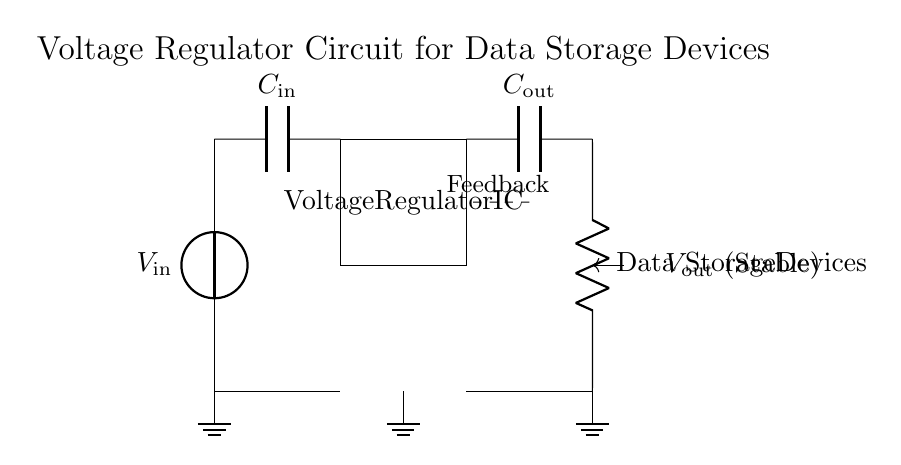What is the input voltage of this circuit? The input voltage is indicated as V in the circuit diagram. It is represented by the voltage source at the top-left corner, labeled with V in the diagram.
Answer: V in What type of component is the voltage regulator? The voltage regulator is represented by a rectangle in the diagram, and it's clearly labeled as a Voltage Regulator IC.
Answer: Voltage Regulator IC How many capacitors are present in the circuit? There are two capacitors shown in the diagram, one at the input and one at the output, labeled C in and C out respectively.
Answer: 2 What is the purpose of the feedback loop in this circuit? The feedback loop is shown by a dashed line connecting the output to the regulator, allowing the circuit to stabilize the output voltage based on the feedback received. This process is essential for maintaining a constant voltage despite variations in input or load.
Answer: Stabilizing output What do the load resistors represent in this circuit? The load resistor in this circuit is labeled as Data Storage Devices, indicating that this component simulates the electrical load seen by the power supply from the data storage system.
Answer: Data Storage Devices What is the output voltage labeled as in the diagram? The output voltage is labeled as V out in the circuit diagram, which signifies that it is the stable voltage output supplied to the load.
Answer: V out (Stable) 